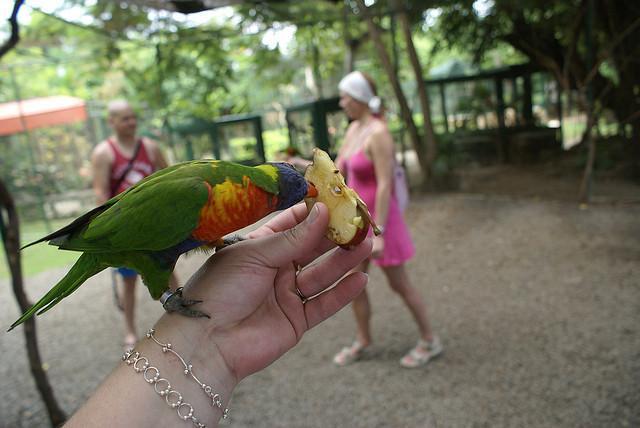How many people are there?
Give a very brief answer. 3. How many train cars are orange?
Give a very brief answer. 0. 